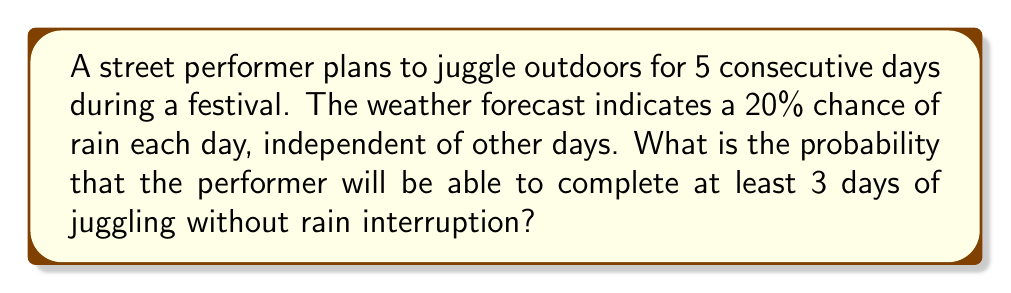What is the answer to this math problem? Let's approach this step-by-step:

1) First, we need to calculate the probability of a single day being suitable for juggling. Since there's a 20% chance of rain, there's an 80% chance of no rain:

   $P(\text{no rain on a single day}) = 1 - 0.2 = 0.8$

2) Now, we need to find the probability of at least 3 days being suitable out of 5 days. This is equivalent to the probability of 3, 4, or 5 days being suitable.

3) We can use the binomial probability formula:

   $P(X = k) = \binom{n}{k} p^k (1-p)^{n-k}$

   Where $n = 5$ (total days), $p = 0.8$ (probability of a suitable day), and $k$ is the number of suitable days.

4) Let's calculate for 3, 4, and 5 suitable days:

   $P(X = 3) = \binom{5}{3} (0.8)^3 (0.2)^2 = 10 \cdot 0.512 \cdot 0.04 = 0.2048$
   
   $P(X = 4) = \binom{5}{4} (0.8)^4 (0.2)^1 = 5 \cdot 0.4096 \cdot 0.2 = 0.4096$
   
   $P(X = 5) = \binom{5}{5} (0.8)^5 (0.2)^0 = 1 \cdot 0.32768 \cdot 1 = 0.32768$

5) The total probability is the sum of these individual probabilities:

   $P(\text{at least 3 suitable days}) = P(X = 3) + P(X = 4) + P(X = 5)$
   
   $= 0.2048 + 0.4096 + 0.32768 = 0.94208$

Therefore, the probability of completing at least 3 days of juggling without rain interruption is approximately 0.94208 or 94.208%.
Answer: 0.94208 